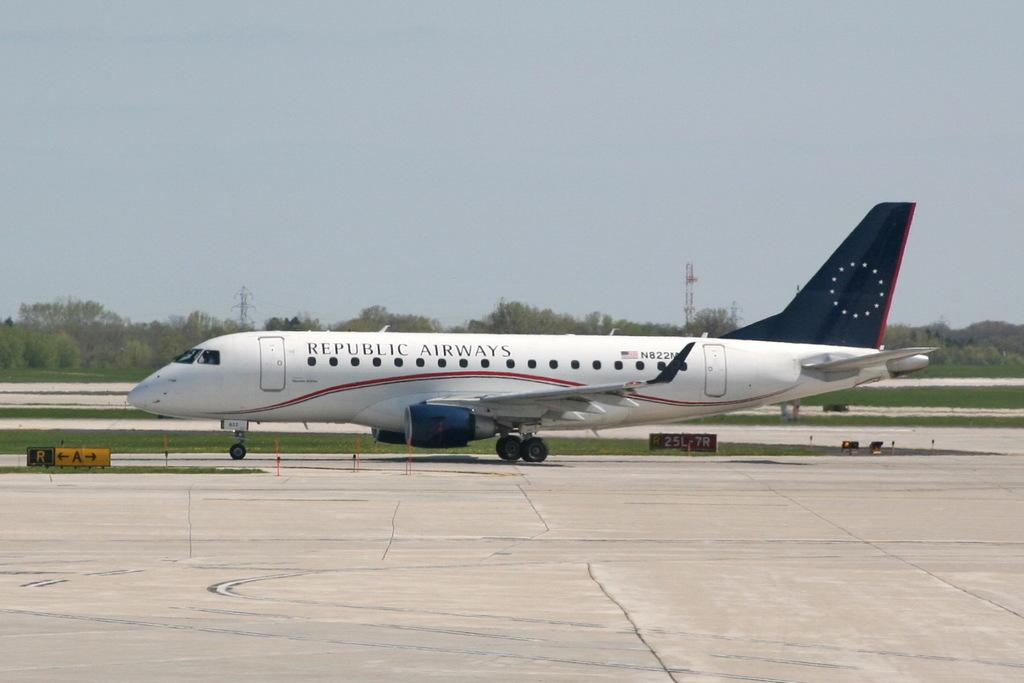<image>
Present a compact description of the photo's key features. Republic Airways on a blue, red, and white airplane. 